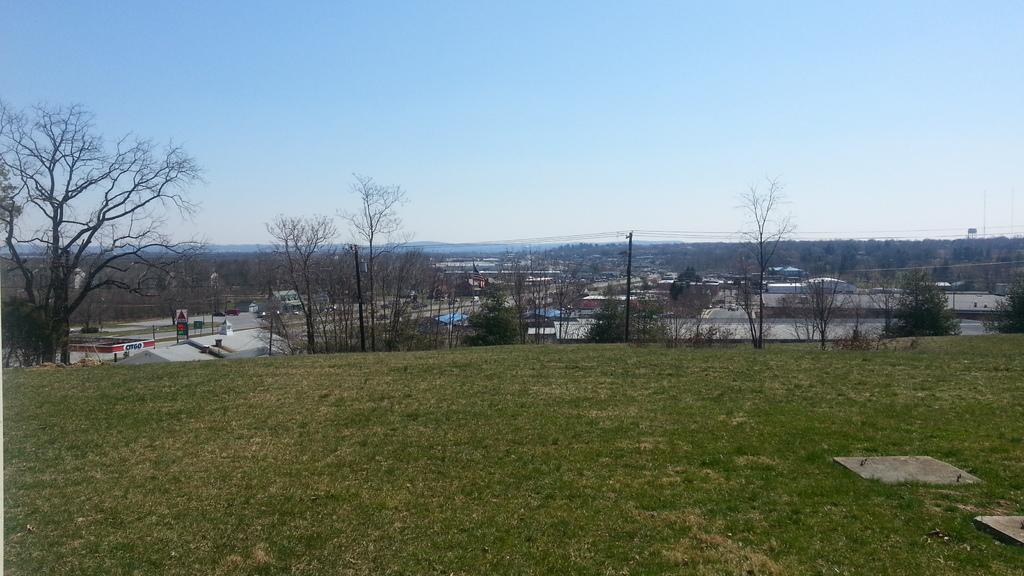Can you describe this image briefly? In this image there is the sky towards the top of the image, there are houses, there is a pole, there are wires, there are trees towards the right of the image, there are trees towards the left of the image, there is grass towards the bottom of the image. 